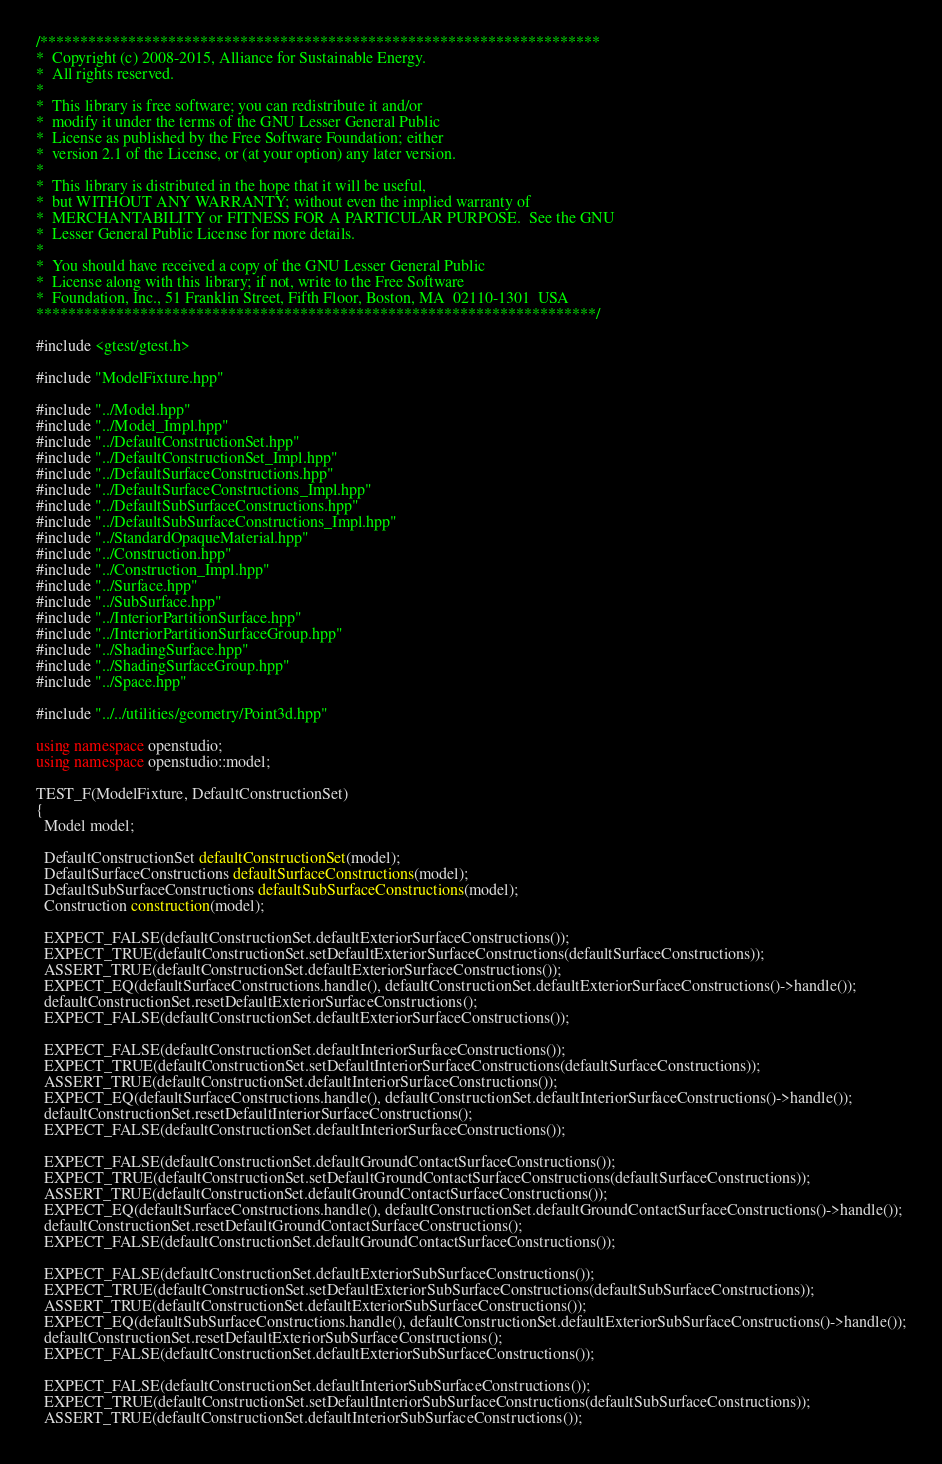<code> <loc_0><loc_0><loc_500><loc_500><_C++_>/**********************************************************************
*  Copyright (c) 2008-2015, Alliance for Sustainable Energy.
*  All rights reserved.
*
*  This library is free software; you can redistribute it and/or
*  modify it under the terms of the GNU Lesser General Public
*  License as published by the Free Software Foundation; either
*  version 2.1 of the License, or (at your option) any later version.
*
*  This library is distributed in the hope that it will be useful,
*  but WITHOUT ANY WARRANTY; without even the implied warranty of
*  MERCHANTABILITY or FITNESS FOR A PARTICULAR PURPOSE.  See the GNU
*  Lesser General Public License for more details.
*
*  You should have received a copy of the GNU Lesser General Public
*  License along with this library; if not, write to the Free Software
*  Foundation, Inc., 51 Franklin Street, Fifth Floor, Boston, MA  02110-1301  USA
**********************************************************************/

#include <gtest/gtest.h>

#include "ModelFixture.hpp"

#include "../Model.hpp"
#include "../Model_Impl.hpp"
#include "../DefaultConstructionSet.hpp"
#include "../DefaultConstructionSet_Impl.hpp"
#include "../DefaultSurfaceConstructions.hpp"
#include "../DefaultSurfaceConstructions_Impl.hpp"
#include "../DefaultSubSurfaceConstructions.hpp"
#include "../DefaultSubSurfaceConstructions_Impl.hpp"
#include "../StandardOpaqueMaterial.hpp"
#include "../Construction.hpp"
#include "../Construction_Impl.hpp"
#include "../Surface.hpp"
#include "../SubSurface.hpp"
#include "../InteriorPartitionSurface.hpp"
#include "../InteriorPartitionSurfaceGroup.hpp"
#include "../ShadingSurface.hpp"
#include "../ShadingSurfaceGroup.hpp"
#include "../Space.hpp"

#include "../../utilities/geometry/Point3d.hpp"

using namespace openstudio;
using namespace openstudio::model;

TEST_F(ModelFixture, DefaultConstructionSet)
{
  Model model;

  DefaultConstructionSet defaultConstructionSet(model);
  DefaultSurfaceConstructions defaultSurfaceConstructions(model);
  DefaultSubSurfaceConstructions defaultSubSurfaceConstructions(model);
  Construction construction(model);

  EXPECT_FALSE(defaultConstructionSet.defaultExteriorSurfaceConstructions());
  EXPECT_TRUE(defaultConstructionSet.setDefaultExteriorSurfaceConstructions(defaultSurfaceConstructions));
  ASSERT_TRUE(defaultConstructionSet.defaultExteriorSurfaceConstructions());
  EXPECT_EQ(defaultSurfaceConstructions.handle(), defaultConstructionSet.defaultExteriorSurfaceConstructions()->handle());
  defaultConstructionSet.resetDefaultExteriorSurfaceConstructions();
  EXPECT_FALSE(defaultConstructionSet.defaultExteriorSurfaceConstructions());

  EXPECT_FALSE(defaultConstructionSet.defaultInteriorSurfaceConstructions());
  EXPECT_TRUE(defaultConstructionSet.setDefaultInteriorSurfaceConstructions(defaultSurfaceConstructions));
  ASSERT_TRUE(defaultConstructionSet.defaultInteriorSurfaceConstructions());
  EXPECT_EQ(defaultSurfaceConstructions.handle(), defaultConstructionSet.defaultInteriorSurfaceConstructions()->handle());
  defaultConstructionSet.resetDefaultInteriorSurfaceConstructions();
  EXPECT_FALSE(defaultConstructionSet.defaultInteriorSurfaceConstructions());

  EXPECT_FALSE(defaultConstructionSet.defaultGroundContactSurfaceConstructions());
  EXPECT_TRUE(defaultConstructionSet.setDefaultGroundContactSurfaceConstructions(defaultSurfaceConstructions));
  ASSERT_TRUE(defaultConstructionSet.defaultGroundContactSurfaceConstructions());
  EXPECT_EQ(defaultSurfaceConstructions.handle(), defaultConstructionSet.defaultGroundContactSurfaceConstructions()->handle());
  defaultConstructionSet.resetDefaultGroundContactSurfaceConstructions();
  EXPECT_FALSE(defaultConstructionSet.defaultGroundContactSurfaceConstructions());

  EXPECT_FALSE(defaultConstructionSet.defaultExteriorSubSurfaceConstructions());
  EXPECT_TRUE(defaultConstructionSet.setDefaultExteriorSubSurfaceConstructions(defaultSubSurfaceConstructions));
  ASSERT_TRUE(defaultConstructionSet.defaultExteriorSubSurfaceConstructions());
  EXPECT_EQ(defaultSubSurfaceConstructions.handle(), defaultConstructionSet.defaultExteriorSubSurfaceConstructions()->handle());
  defaultConstructionSet.resetDefaultExteriorSubSurfaceConstructions();
  EXPECT_FALSE(defaultConstructionSet.defaultExteriorSubSurfaceConstructions());

  EXPECT_FALSE(defaultConstructionSet.defaultInteriorSubSurfaceConstructions());
  EXPECT_TRUE(defaultConstructionSet.setDefaultInteriorSubSurfaceConstructions(defaultSubSurfaceConstructions));
  ASSERT_TRUE(defaultConstructionSet.defaultInteriorSubSurfaceConstructions());</code> 